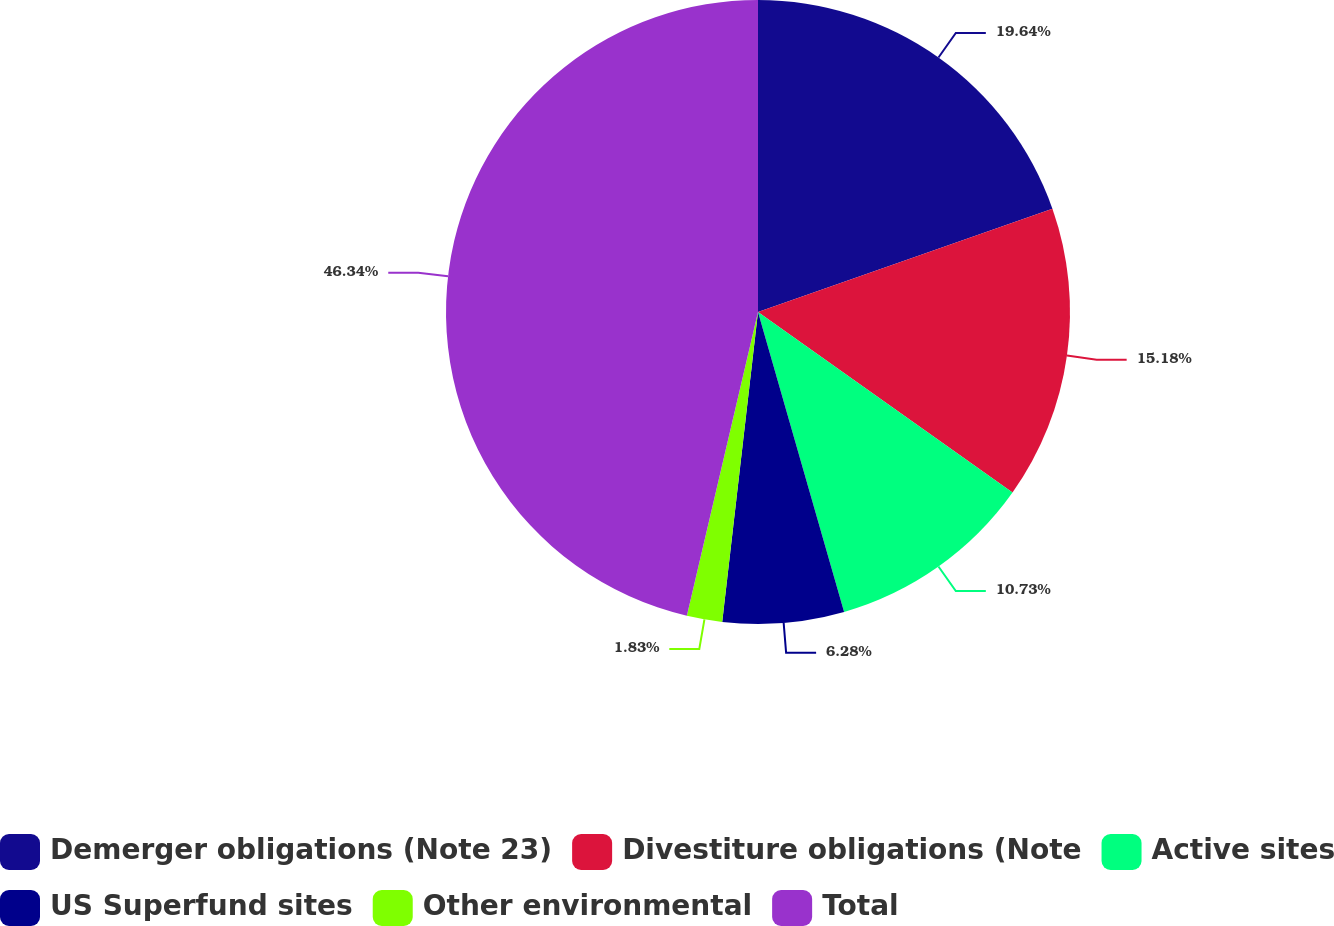<chart> <loc_0><loc_0><loc_500><loc_500><pie_chart><fcel>Demerger obligations (Note 23)<fcel>Divestiture obligations (Note<fcel>Active sites<fcel>US Superfund sites<fcel>Other environmental<fcel>Total<nl><fcel>19.63%<fcel>15.18%<fcel>10.73%<fcel>6.28%<fcel>1.83%<fcel>46.33%<nl></chart> 